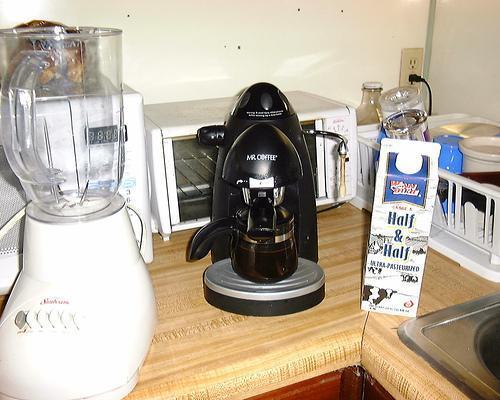How many microwaves are in the photo?
Give a very brief answer. 2. 